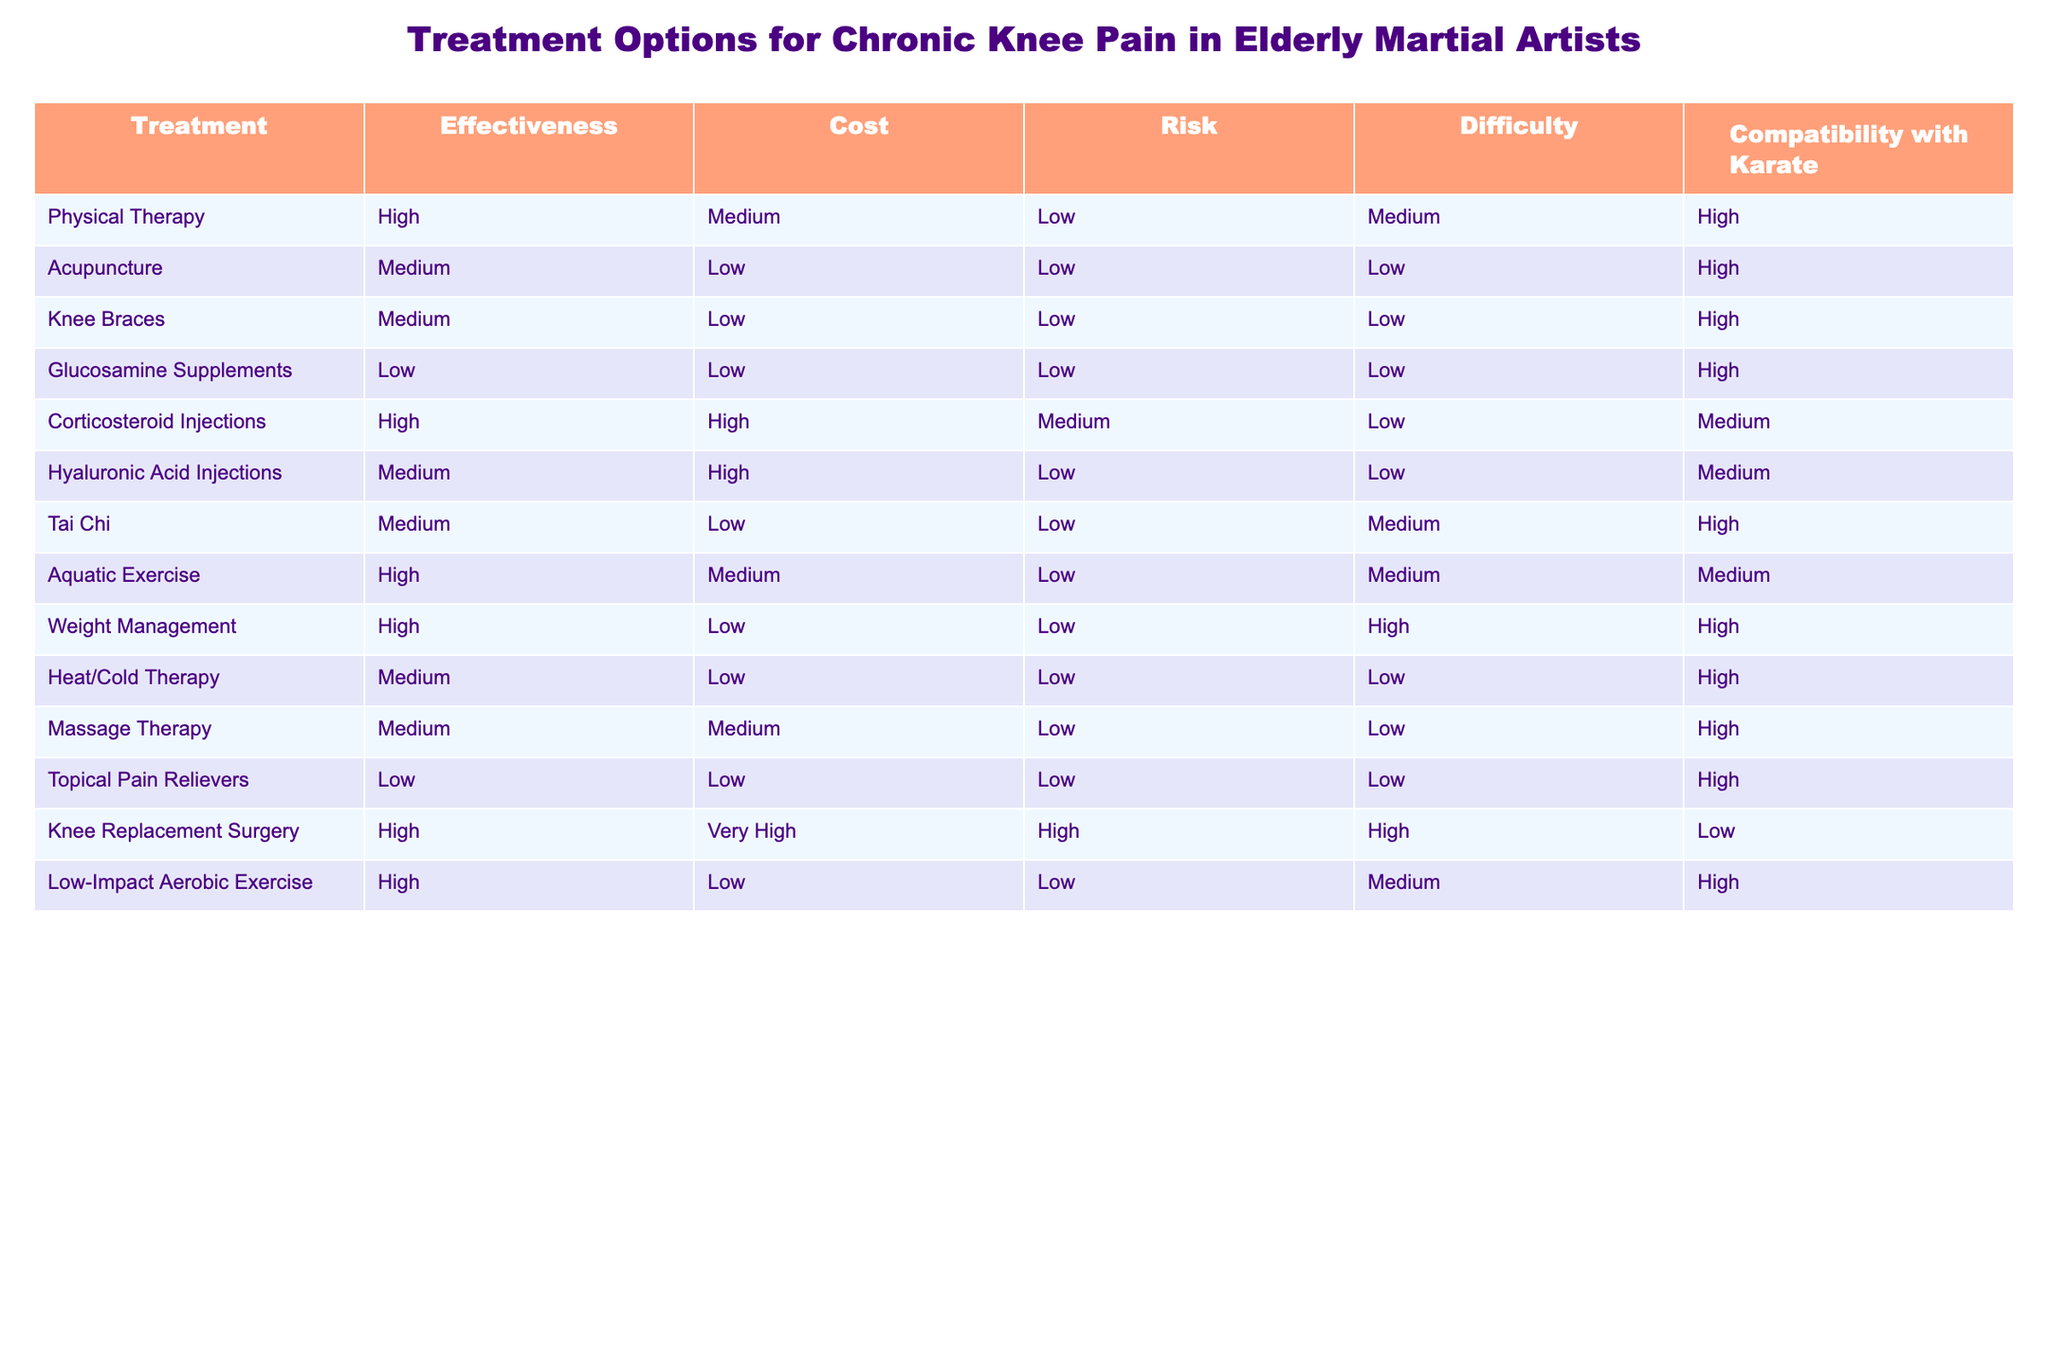What is the effectiveness rating for Knee Replacement Surgery? The effectiveness rating for Knee Replacement Surgery is listed in the table under the Effectiveness column, and it shows "High".
Answer: High Which treatment option has the lowest cost? Upon reviewing the Cost column, both Acupuncture, Knee Braces, Glucosamine Supplements, and Topical Pain Relievers all have a "Low" cost.
Answer: Acupuncture, Knee Braces, Glucosamine Supplements, Topical Pain Relievers How many treatment options have a compatibility with Karate rating of High? The compatibility ratings for each treatment are observed, and options that have "High" compatibility are Physical Therapy, Acupuncture, Knee Braces, Tai Chi, Heat/Cold Therapy, Massage Therapy, and Low-Impact Aerobic Exercise. Counting these options gives us a total of 7.
Answer: 7 Is Massage Therapy more effective than Glucosamine Supplements? Comparing the Effectiveness ratings in the table, Massage Therapy is rated "Medium" while Glucosamine Supplements are rated "Low". Since Medium is higher than Low, the answer is yes.
Answer: Yes What is the average risk rating of all treatments compatible with Karate? First, we identify treatments that have "High" compatibility: Physical Therapy, Acupuncture, Knee Braces, Tai Chi, Heat/Cold Therapy, Massage Therapy, and Low-Impact Aerobic Exercise. Their corresponding risk ratings are Low, Low, Low, Low, Low, Low, and Low, which all equal 1 as Low is the lowest risk. Since all treatments share the same risk, the average remains Low. Therefore, if we assign numerical values (e.g., Low=1, Medium=2, High=3), the average is (1+1+1+1+1+1+1)/7 = 1.
Answer: Low Are there any treatments that are both high in effectiveness and low in risk? By looking through the table, the treatments with high effectiveness and low risk are Physical Therapy and Weight Management. Therefore, there are two treatments that meet these criteria.
Answer: Yes, 2 treatments 